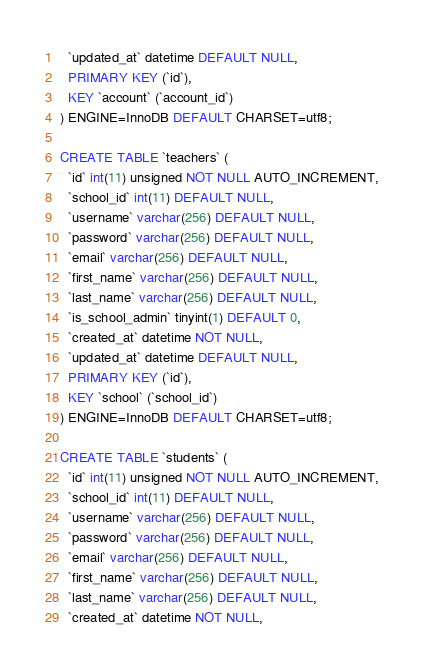Convert code to text. <code><loc_0><loc_0><loc_500><loc_500><_SQL_>  `updated_at` datetime DEFAULT NULL,
  PRIMARY KEY (`id`),
  KEY `account` (`account_id`)
) ENGINE=InnoDB DEFAULT CHARSET=utf8;

CREATE TABLE `teachers` (
  `id` int(11) unsigned NOT NULL AUTO_INCREMENT,
  `school_id` int(11) DEFAULT NULL,
  `username` varchar(256) DEFAULT NULL,
  `password` varchar(256) DEFAULT NULL,
  `email` varchar(256) DEFAULT NULL,
  `first_name` varchar(256) DEFAULT NULL,
  `last_name` varchar(256) DEFAULT NULL,
  `is_school_admin` tinyint(1) DEFAULT 0,
  `created_at` datetime NOT NULL,
  `updated_at` datetime DEFAULT NULL,
  PRIMARY KEY (`id`),
  KEY `school` (`school_id`)
) ENGINE=InnoDB DEFAULT CHARSET=utf8;

CREATE TABLE `students` (
  `id` int(11) unsigned NOT NULL AUTO_INCREMENT,
  `school_id` int(11) DEFAULT NULL,
  `username` varchar(256) DEFAULT NULL,
  `password` varchar(256) DEFAULT NULL,
  `email` varchar(256) DEFAULT NULL,
  `first_name` varchar(256) DEFAULT NULL,
  `last_name` varchar(256) DEFAULT NULL,
  `created_at` datetime NOT NULL,</code> 